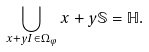<formula> <loc_0><loc_0><loc_500><loc_500>\bigcup _ { x + y I \in \Omega _ { \varphi } } x + y \mathbb { S } = \mathbb { H } .</formula> 